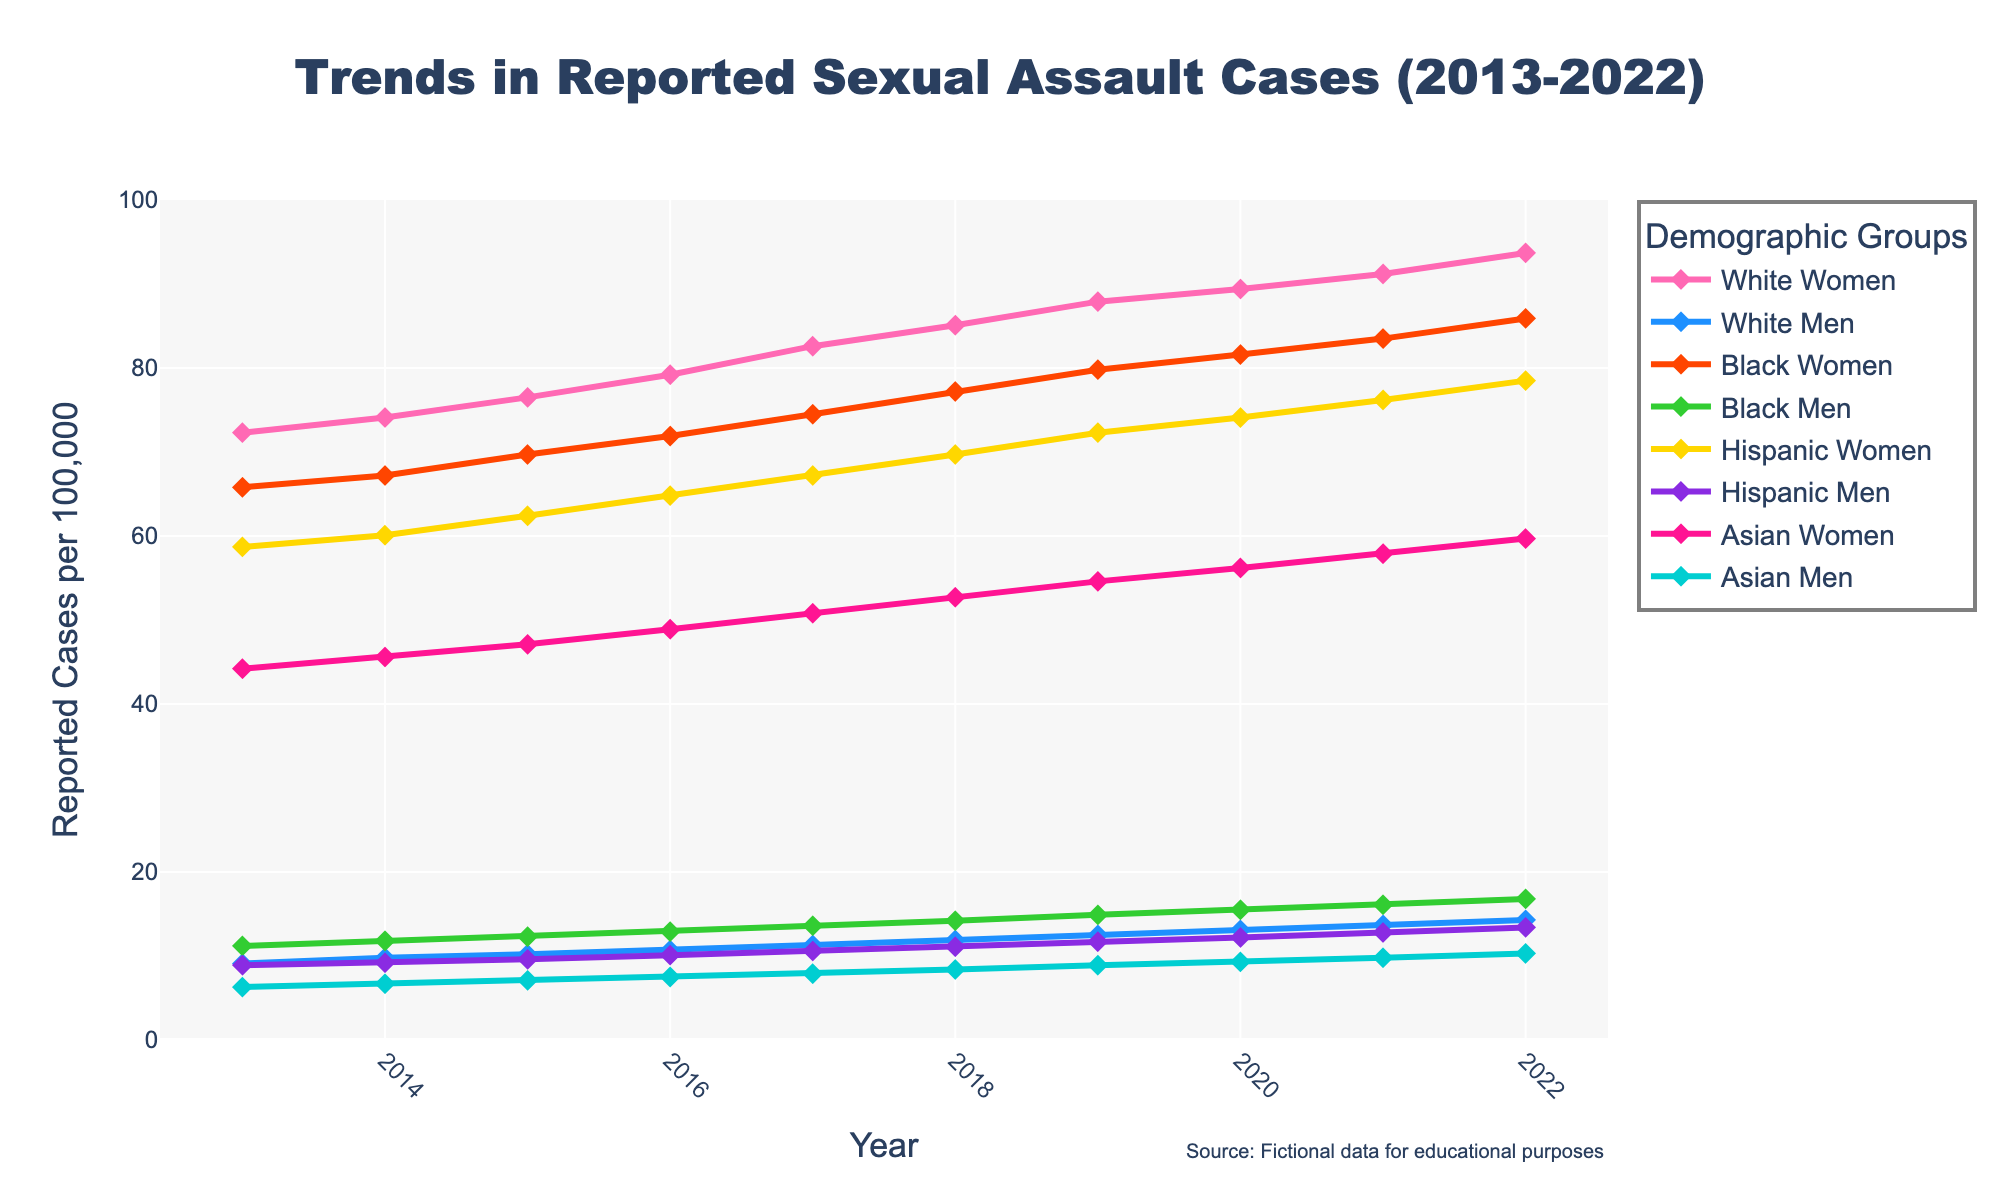Which group had the highest number of reported cases in 2022? By looking at the endpoints of the lines for 2022, we see that the line for White Women reaches the highest value among all groups.
Answer: White Women Which demographic experienced the greatest increase in reported cases from 2013 to 2022? To find the greatest increase, we subtract the 2013 value from the 2022 value for each group. The calculations show that White Women had the largest increase (93.7 - 72.3 = 21.4).
Answer: White Women What is the trend in reported cases for Black Men from 2013 to 2022? Observing the trend for Black Men, the line steadily increases from about 11.2 in 2013 to 16.8 in 2022.
Answer: Increasing In which year did Hispanic Women surpass 70 reported cases? By looking at the line for Hispanic Women, we see that it surpassed 70 reported cases between 2018 and 2019.
Answer: 2019 How do the reported cases for Asian Men in 2016 compare to those for Asian Women in the same year? For 2016, the graph shows that Asian Men had about 7.5 reported cases, while Asian Women had about 48.9 reported cases.
Answer: Asian Women had more What is the average number of reported cases for White Men across the decade? Adding the values for White Men (9.1 + 9.8 + 10.2 + 10.7 + 11.3 + 11.9 + 12.5 + 13.1 + 13.7 + 14.3) and dividing by 10 gives (116.6 / 10 = 11.66).
Answer: 11.66 Which two groups are closest in the number of reported cases in 2022? Looking at the values for 2022, Hispanic Men and Asian Women are the closest with 13.4 and 10.3, respectively, indicating a difference of 3.1.
Answer: Hispanic Men and Asian Women In which year did the total reported cases for White and Black Women combined first exceed 150? We sum the reported cases for White Women and Black Women for each year and see that the total exceeds 150 in 2018 (85.1 + 77.2 = 162.3).
Answer: 2018 